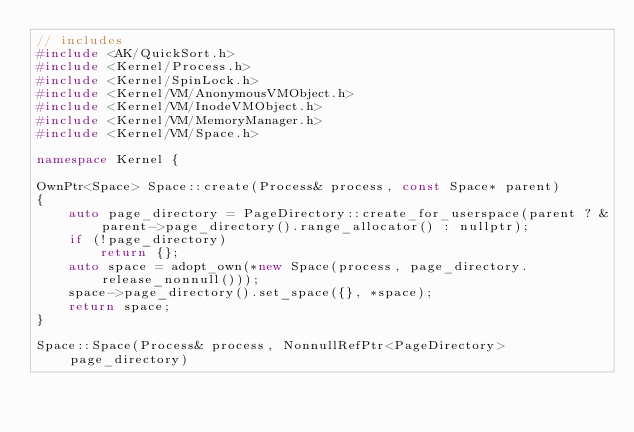<code> <loc_0><loc_0><loc_500><loc_500><_C++_>// includes
#include <AK/QuickSort.h>
#include <Kernel/Process.h>
#include <Kernel/SpinLock.h>
#include <Kernel/VM/AnonymousVMObject.h>
#include <Kernel/VM/InodeVMObject.h>
#include <Kernel/VM/MemoryManager.h>
#include <Kernel/VM/Space.h>

namespace Kernel {

OwnPtr<Space> Space::create(Process& process, const Space* parent)
{
    auto page_directory = PageDirectory::create_for_userspace(parent ? &parent->page_directory().range_allocator() : nullptr);
    if (!page_directory)
        return {};
    auto space = adopt_own(*new Space(process, page_directory.release_nonnull()));
    space->page_directory().set_space({}, *space);
    return space;
}

Space::Space(Process& process, NonnullRefPtr<PageDirectory> page_directory)</code> 